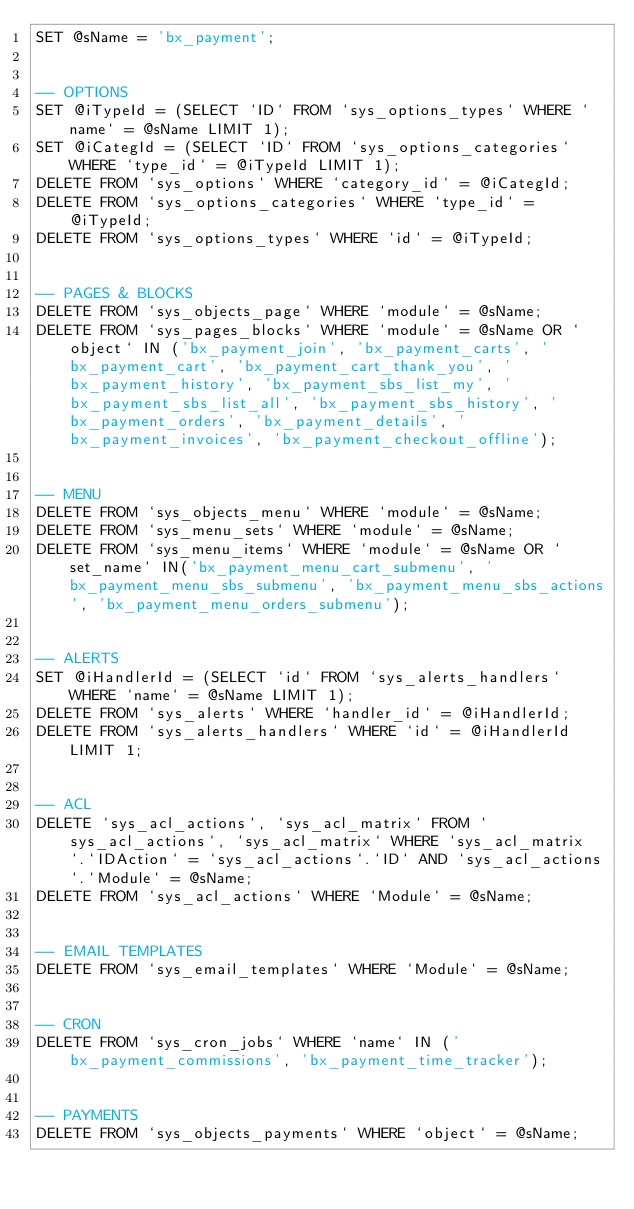Convert code to text. <code><loc_0><loc_0><loc_500><loc_500><_SQL_>SET @sName = 'bx_payment';


-- OPTIONS
SET @iTypeId = (SELECT `ID` FROM `sys_options_types` WHERE `name` = @sName LIMIT 1);
SET @iCategId = (SELECT `ID` FROM `sys_options_categories` WHERE `type_id` = @iTypeId LIMIT 1);
DELETE FROM `sys_options` WHERE `category_id` = @iCategId;
DELETE FROM `sys_options_categories` WHERE `type_id` = @iTypeId;
DELETE FROM `sys_options_types` WHERE `id` = @iTypeId;


-- PAGES & BLOCKS
DELETE FROM `sys_objects_page` WHERE `module` = @sName;
DELETE FROM `sys_pages_blocks` WHERE `module` = @sName OR `object` IN ('bx_payment_join', 'bx_payment_carts', 'bx_payment_cart', 'bx_payment_cart_thank_you', 'bx_payment_history', 'bx_payment_sbs_list_my', 'bx_payment_sbs_list_all', 'bx_payment_sbs_history', 'bx_payment_orders', 'bx_payment_details', 'bx_payment_invoices', 'bx_payment_checkout_offline');


-- MENU
DELETE FROM `sys_objects_menu` WHERE `module` = @sName;
DELETE FROM `sys_menu_sets` WHERE `module` = @sName;
DELETE FROM `sys_menu_items` WHERE `module` = @sName OR `set_name` IN('bx_payment_menu_cart_submenu', 'bx_payment_menu_sbs_submenu', 'bx_payment_menu_sbs_actions', 'bx_payment_menu_orders_submenu');


-- ALERTS
SET @iHandlerId = (SELECT `id` FROM `sys_alerts_handlers` WHERE `name` = @sName LIMIT 1);
DELETE FROM `sys_alerts` WHERE `handler_id` = @iHandlerId;
DELETE FROM `sys_alerts_handlers` WHERE `id` = @iHandlerId LIMIT 1;


-- ACL
DELETE `sys_acl_actions`, `sys_acl_matrix` FROM `sys_acl_actions`, `sys_acl_matrix` WHERE `sys_acl_matrix`.`IDAction` = `sys_acl_actions`.`ID` AND `sys_acl_actions`.`Module` = @sName;
DELETE FROM `sys_acl_actions` WHERE `Module` = @sName;


-- EMAIL TEMPLATES
DELETE FROM `sys_email_templates` WHERE `Module` = @sName;


-- CRON
DELETE FROM `sys_cron_jobs` WHERE `name` IN ('bx_payment_commissions', 'bx_payment_time_tracker');


-- PAYMENTS
DELETE FROM `sys_objects_payments` WHERE `object` = @sName;
</code> 